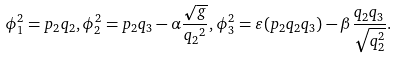Convert formula to latex. <formula><loc_0><loc_0><loc_500><loc_500>\phi _ { 1 } ^ { 2 } = p _ { 2 } q _ { 2 } , \phi _ { 2 } ^ { 2 } = p _ { 2 } q _ { 3 } - \alpha \frac { \sqrt { g } } { { q _ { 2 } } ^ { 2 } } , \phi _ { 3 } ^ { 2 } = \varepsilon ( p _ { 2 } q _ { 2 } q _ { 3 } ) - \beta \frac { q _ { 2 } q _ { 3 } } { \sqrt { q _ { 2 } ^ { 2 } } } .</formula> 